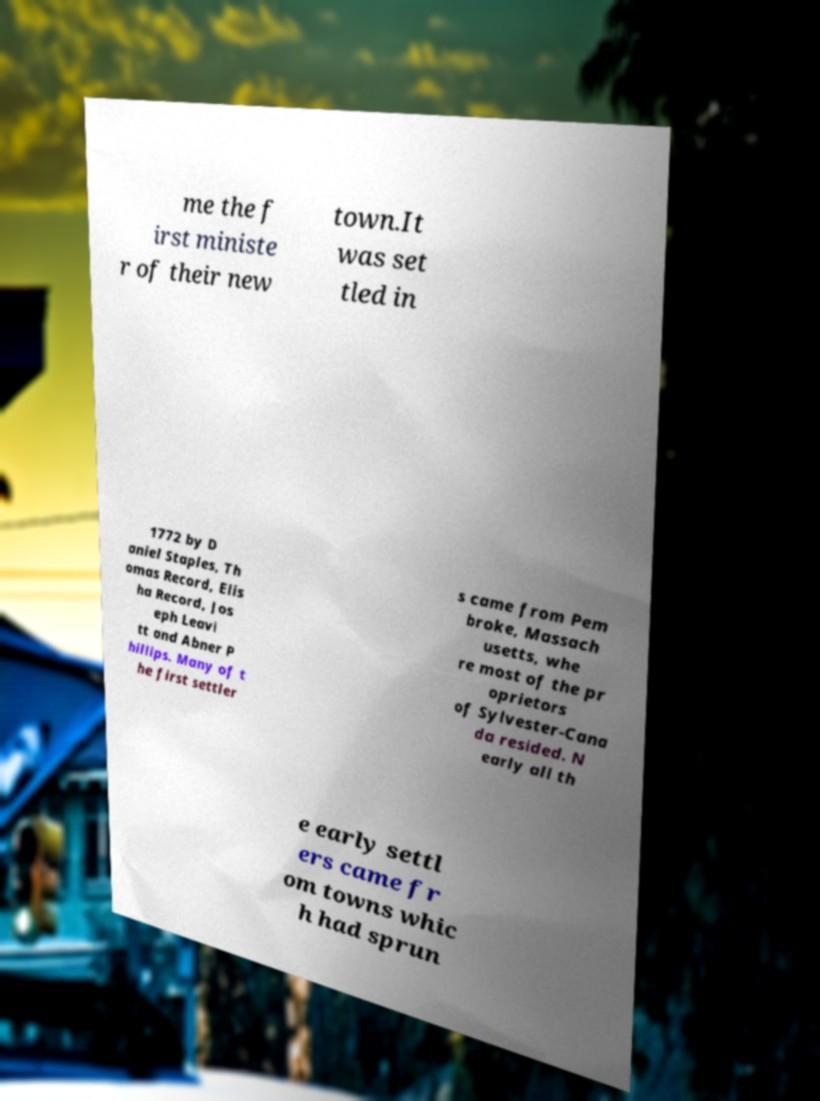Please identify and transcribe the text found in this image. me the f irst ministe r of their new town.It was set tled in 1772 by D aniel Staples, Th omas Record, Elis ha Record, Jos eph Leavi tt and Abner P hillips. Many of t he first settler s came from Pem broke, Massach usetts, whe re most of the pr oprietors of Sylvester-Cana da resided. N early all th e early settl ers came fr om towns whic h had sprun 